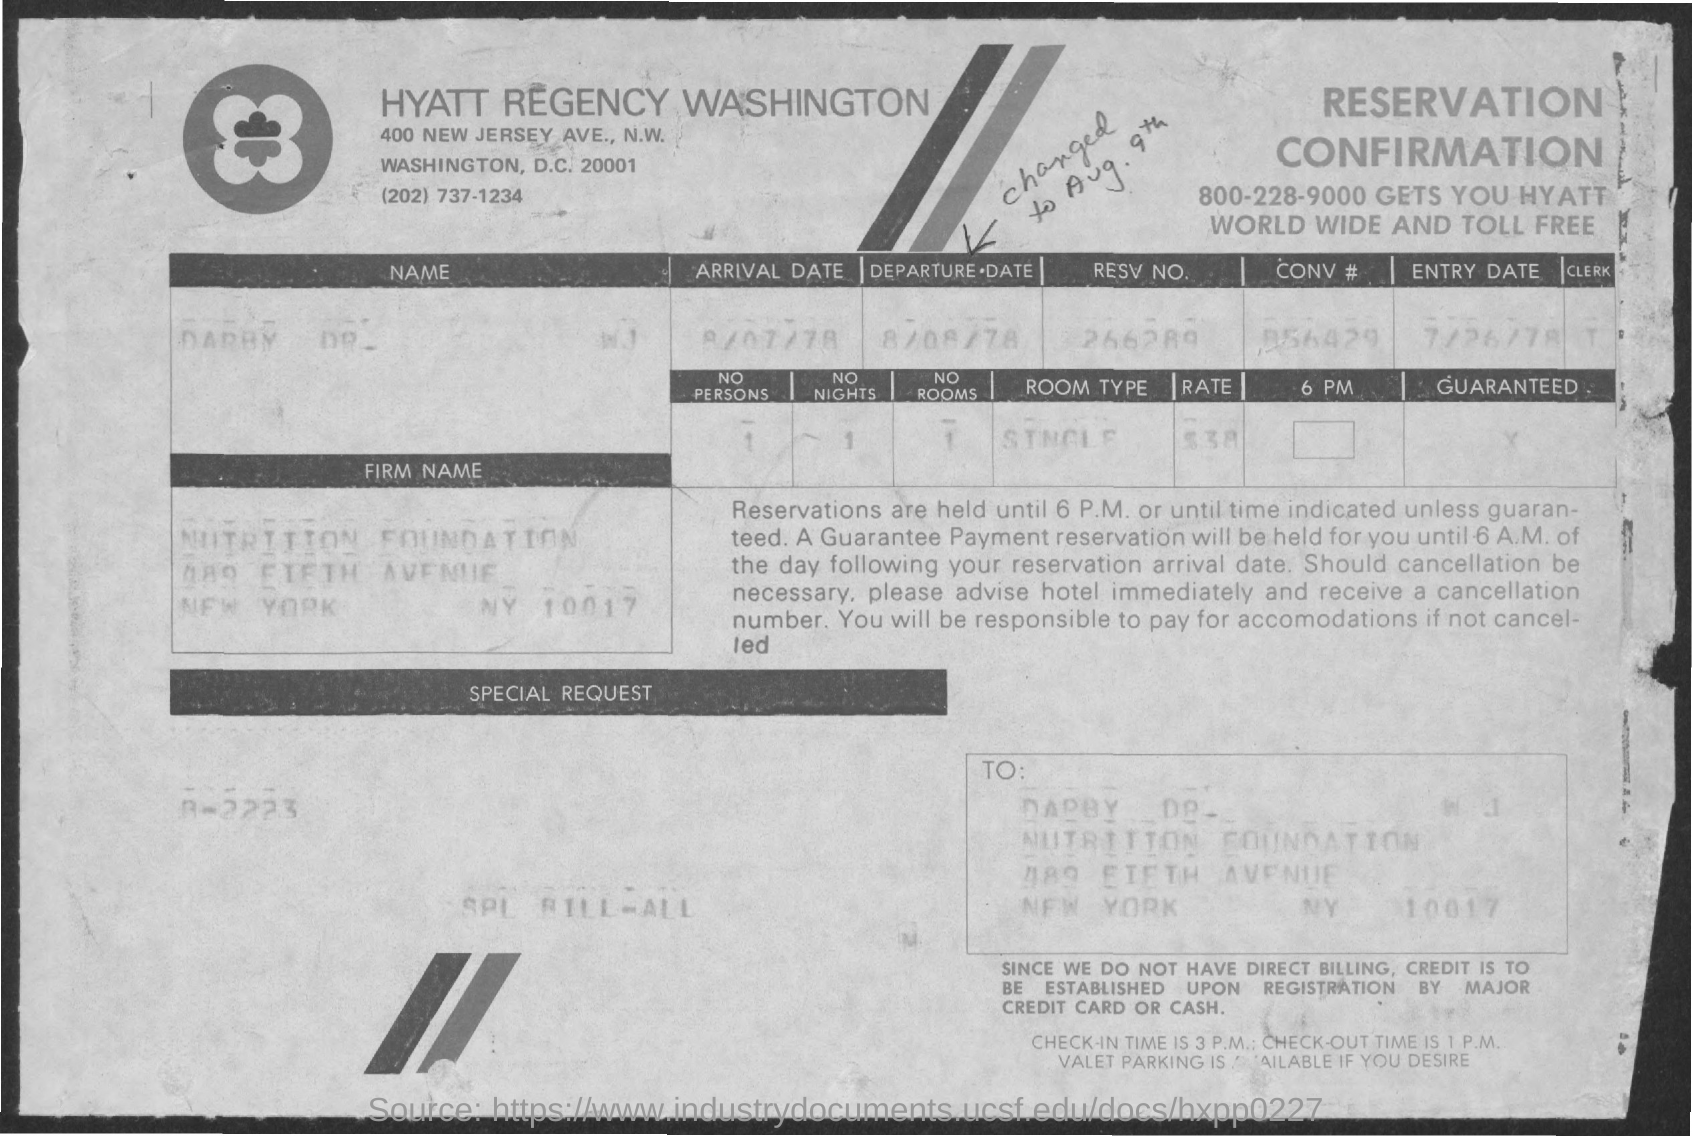Point out several critical features in this image. The room type mentioned is a single room. What is the reservation number mentioned? It is 266289. The arrival date mentioned is August 7th, 1978. The entry date mentioned is July 26, 1978. The departure date mentioned in the text is August 8, 1978. 